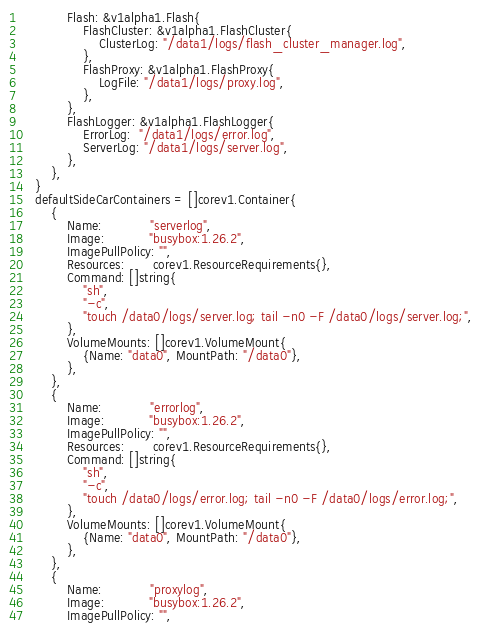Convert code to text. <code><loc_0><loc_0><loc_500><loc_500><_Go_>			Flash: &v1alpha1.Flash{
				FlashCluster: &v1alpha1.FlashCluster{
					ClusterLog: "/data1/logs/flash_cluster_manager.log",
				},
				FlashProxy: &v1alpha1.FlashProxy{
					LogFile: "/data1/logs/proxy.log",
				},
			},
			FlashLogger: &v1alpha1.FlashLogger{
				ErrorLog:  "/data1/logs/error.log",
				ServerLog: "/data1/logs/server.log",
			},
		},
	}
	defaultSideCarContainers = []corev1.Container{
		{
			Name:            "serverlog",
			Image:           "busybox:1.26.2",
			ImagePullPolicy: "",
			Resources:       corev1.ResourceRequirements{},
			Command: []string{
				"sh",
				"-c",
				"touch /data0/logs/server.log; tail -n0 -F /data0/logs/server.log;",
			},
			VolumeMounts: []corev1.VolumeMount{
				{Name: "data0", MountPath: "/data0"},
			},
		},
		{
			Name:            "errorlog",
			Image:           "busybox:1.26.2",
			ImagePullPolicy: "",
			Resources:       corev1.ResourceRequirements{},
			Command: []string{
				"sh",
				"-c",
				"touch /data0/logs/error.log; tail -n0 -F /data0/logs/error.log;",
			},
			VolumeMounts: []corev1.VolumeMount{
				{Name: "data0", MountPath: "/data0"},
			},
		},
		{
			Name:            "proxylog",
			Image:           "busybox:1.26.2",
			ImagePullPolicy: "",</code> 